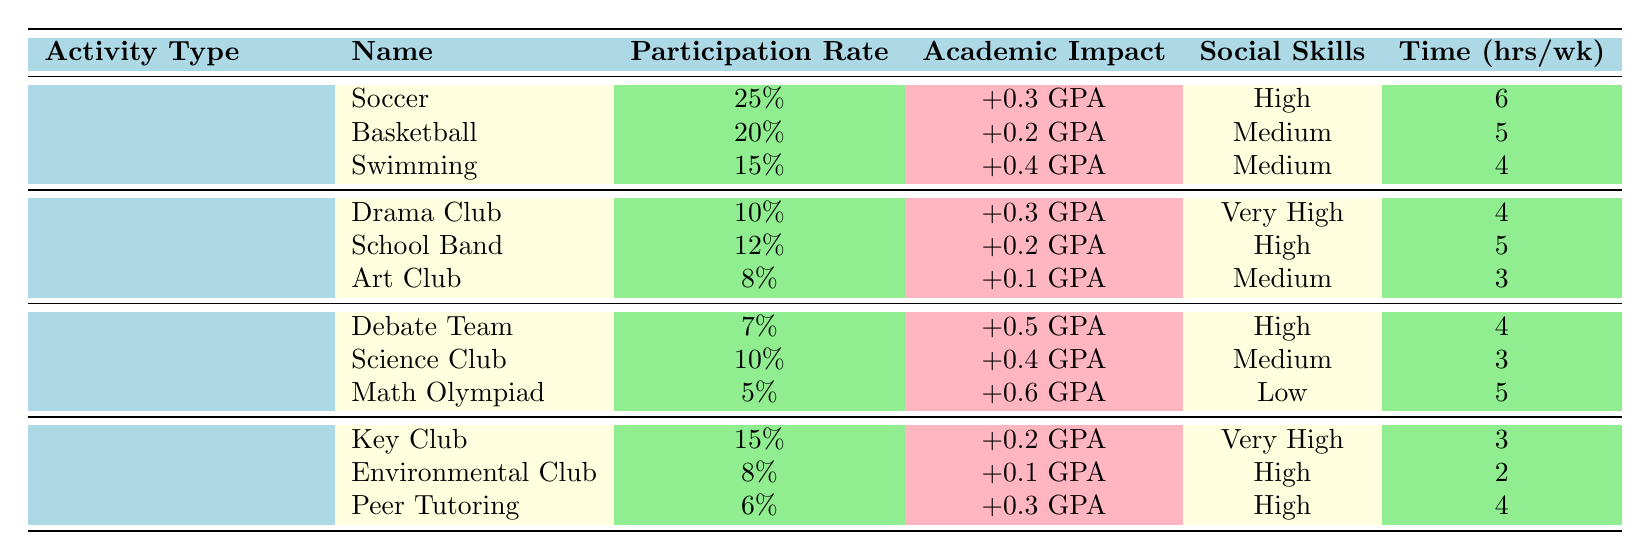What is the participation rate for the Soccer activity? The table lists Soccer under the Sports category, and its participation rate is shown as 25%.
Answer: 25% Which activity type has the highest academic performance impact? Looking at the Academic Performance Impact column, the Math Olympiad has the highest impact of +0.6 GPA, which is listed under the Academic Clubs activity type.
Answer: Academic Clubs How much time do students spend weekly on Drama Club activities? The table shows that the time commitment for the Drama Club under the Arts category is 4 hours per week.
Answer: 4 hours Is the social skills improvement from Key Club high? The table indicates that social skills improvement for Key Club is described as "Very High," confirming the answer is yes.
Answer: Yes What is the average participation rate for activities in the Arts category? The participation rates for Arts activities are 10%, 12%, and 8%. The average is (10 + 12 + 8) / 3 = 10%.
Answer: 10% Which sport's participation rate is closest to the average participation rate of all Sports activities? The participation rates for Sports are 25%, 20%, and 15%. The average is (25 + 20 + 15) / 3 = 20%. Basketball, with a participation rate of 20%, is closest to this average.
Answer: Basketball What is the time commitment for the activity with the lowest social skills improvement? The table indicates that the Math Olympiad has "Low" social skills improvement and requires a time commitment of 5 hours per week.
Answer: 5 hours Which activity type has a total participation rate of 40%? Summing the participation rates for Sports (25% + 20% + 15%), yields a total of 60%. None of the other categories sum to 40%.
Answer: No activity type has 40% Which activity shows the greatest increase in GPA with participation? The table shows that participation in Math Olympiad leads to a GPA increase of +0.6, which is the greatest when compared to all other activities.
Answer: Math Olympiad If a student participates in Soccer and Math Olympiad, what is the total GPA impact? The GPA impact from Soccer is +0.3 and from Math Olympiad is +0.6. The total impact is +0.3 + 0.6 = +0.9 GPA.
Answer: +0.9 GPA 